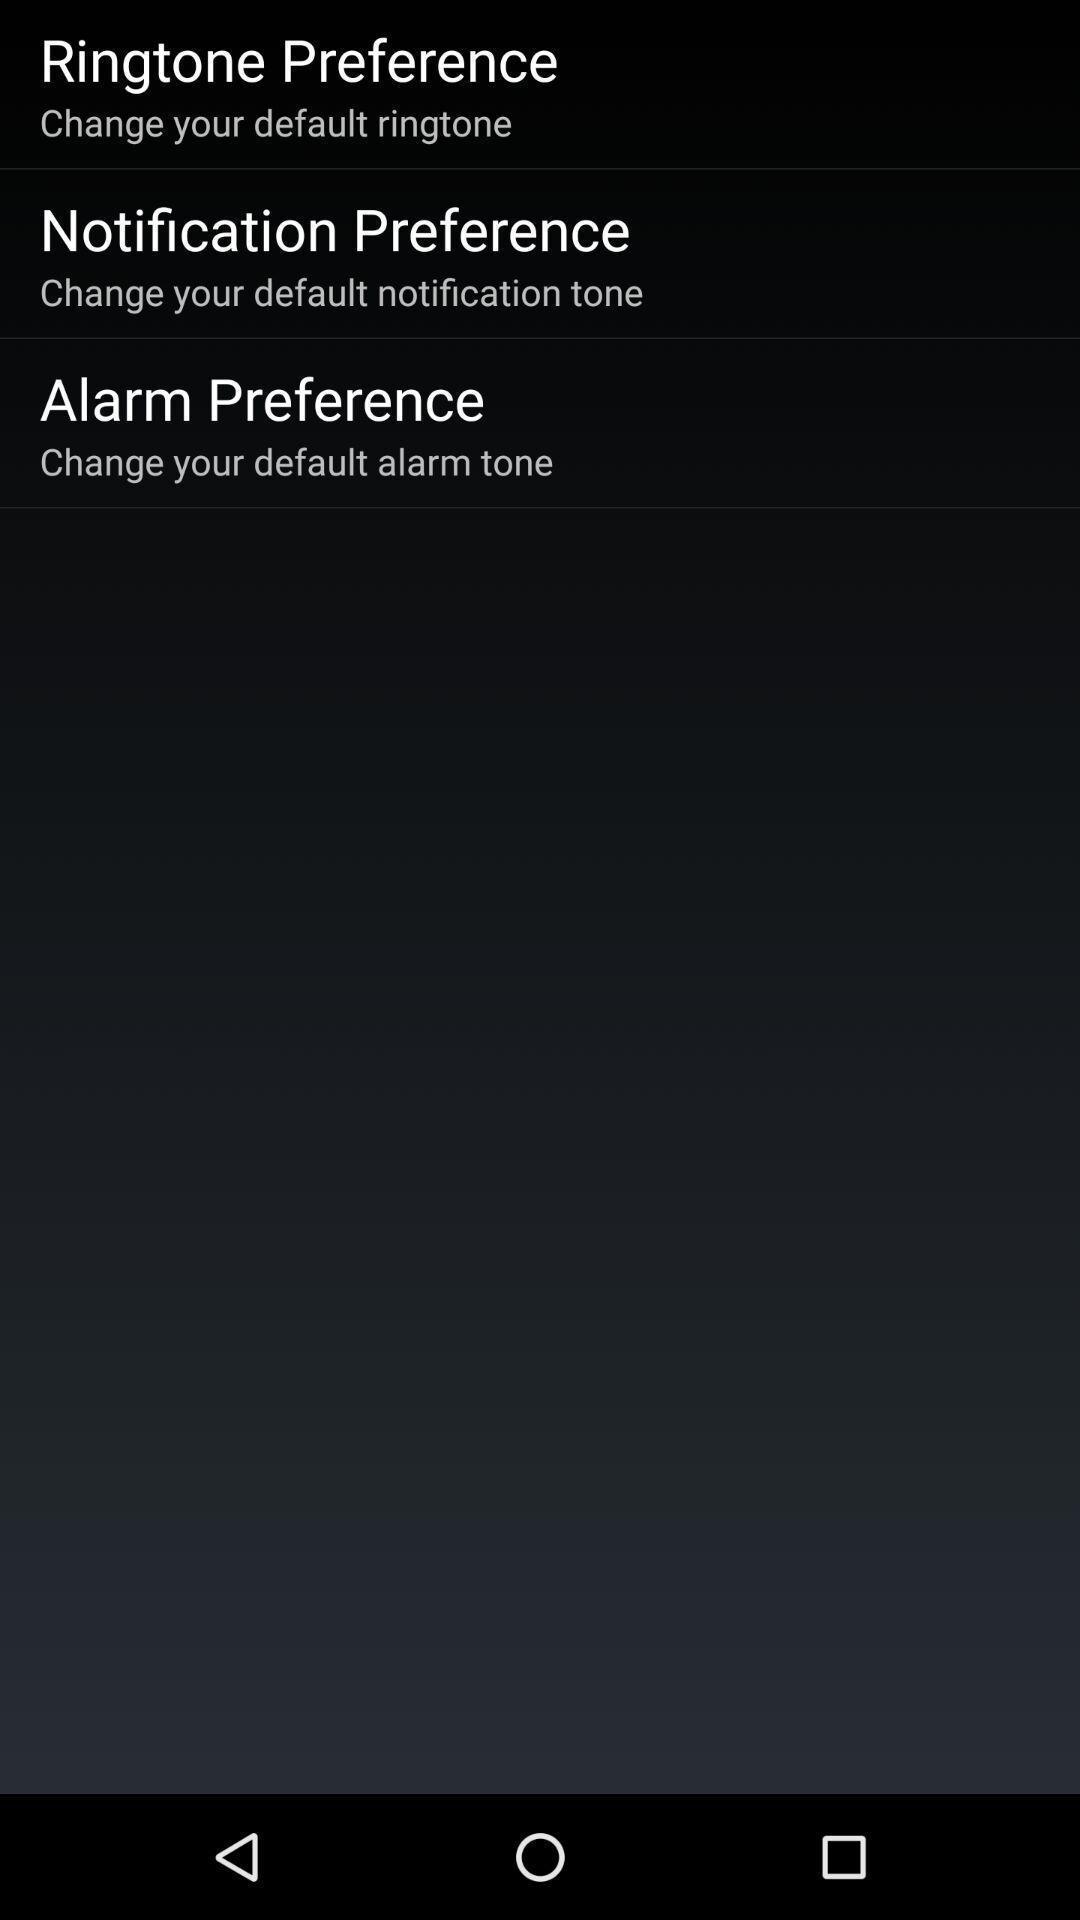Provide a description of this screenshot. Setting preferences are displaying. 